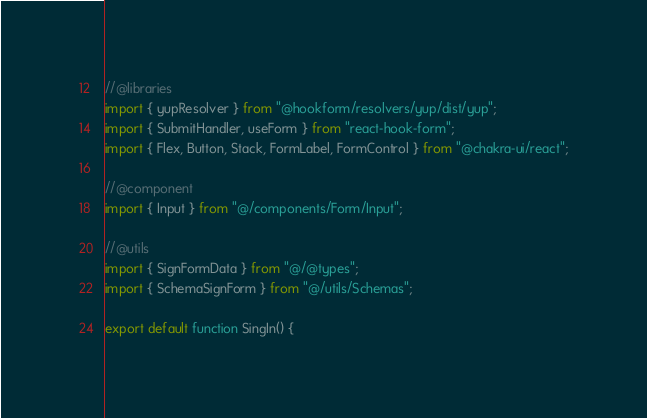<code> <loc_0><loc_0><loc_500><loc_500><_TypeScript_>//@libraries
import { yupResolver } from "@hookform/resolvers/yup/dist/yup";
import { SubmitHandler, useForm } from "react-hook-form";
import { Flex, Button, Stack, FormLabel, FormControl } from "@chakra-ui/react";

//@component
import { Input } from "@/components/Form/Input";

//@utils
import { SignFormData } from "@/@types";
import { SchemaSignForm } from "@/utils/Schemas";

export default function SingIn() {</code> 